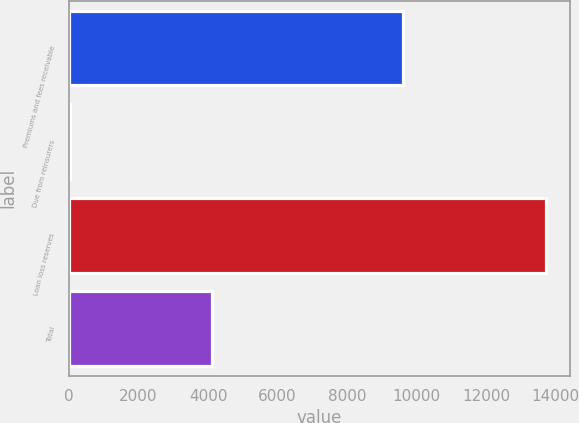Convert chart. <chart><loc_0><loc_0><loc_500><loc_500><bar_chart><fcel>Premiums and fees receivable<fcel>Due from reinsurers<fcel>Loan loss reserves<fcel>Total<nl><fcel>9598<fcel>22<fcel>13723<fcel>4103<nl></chart> 